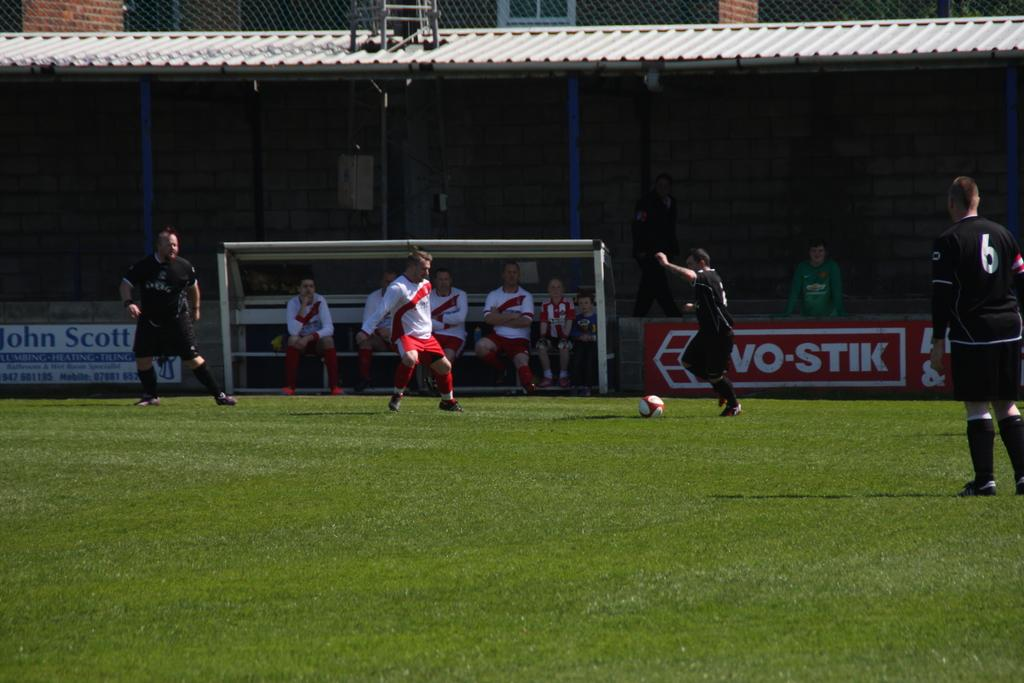How many people are present in the image? There are many people in the image. What object is on the ground in the image? There is a ball on the ground. Can you describe the group of people in the image? There is a group of people sitting on a bench. What can be seen in the background of the image? There is a shed and a building in the background of the image. What type of wood is the pet using as a toy in the image? There is no pet or wood present in the image. Can you describe the parent's interaction with the children in the image? There is no parent or children present in the image. 